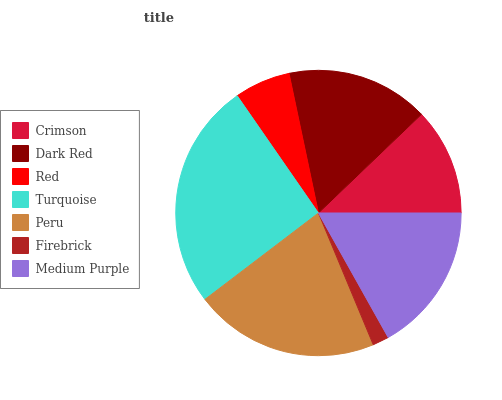Is Firebrick the minimum?
Answer yes or no. Yes. Is Turquoise the maximum?
Answer yes or no. Yes. Is Dark Red the minimum?
Answer yes or no. No. Is Dark Red the maximum?
Answer yes or no. No. Is Dark Red greater than Crimson?
Answer yes or no. Yes. Is Crimson less than Dark Red?
Answer yes or no. Yes. Is Crimson greater than Dark Red?
Answer yes or no. No. Is Dark Red less than Crimson?
Answer yes or no. No. Is Dark Red the high median?
Answer yes or no. Yes. Is Dark Red the low median?
Answer yes or no. Yes. Is Medium Purple the high median?
Answer yes or no. No. Is Firebrick the low median?
Answer yes or no. No. 